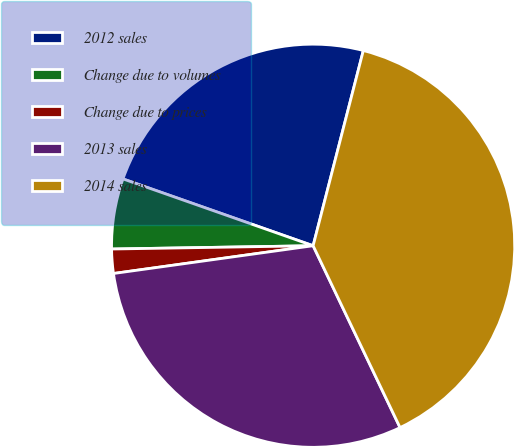<chart> <loc_0><loc_0><loc_500><loc_500><pie_chart><fcel>2012 sales<fcel>Change due to volumes<fcel>Change due to prices<fcel>2013 sales<fcel>2014 sales<nl><fcel>23.63%<fcel>5.64%<fcel>1.94%<fcel>29.9%<fcel>38.9%<nl></chart> 